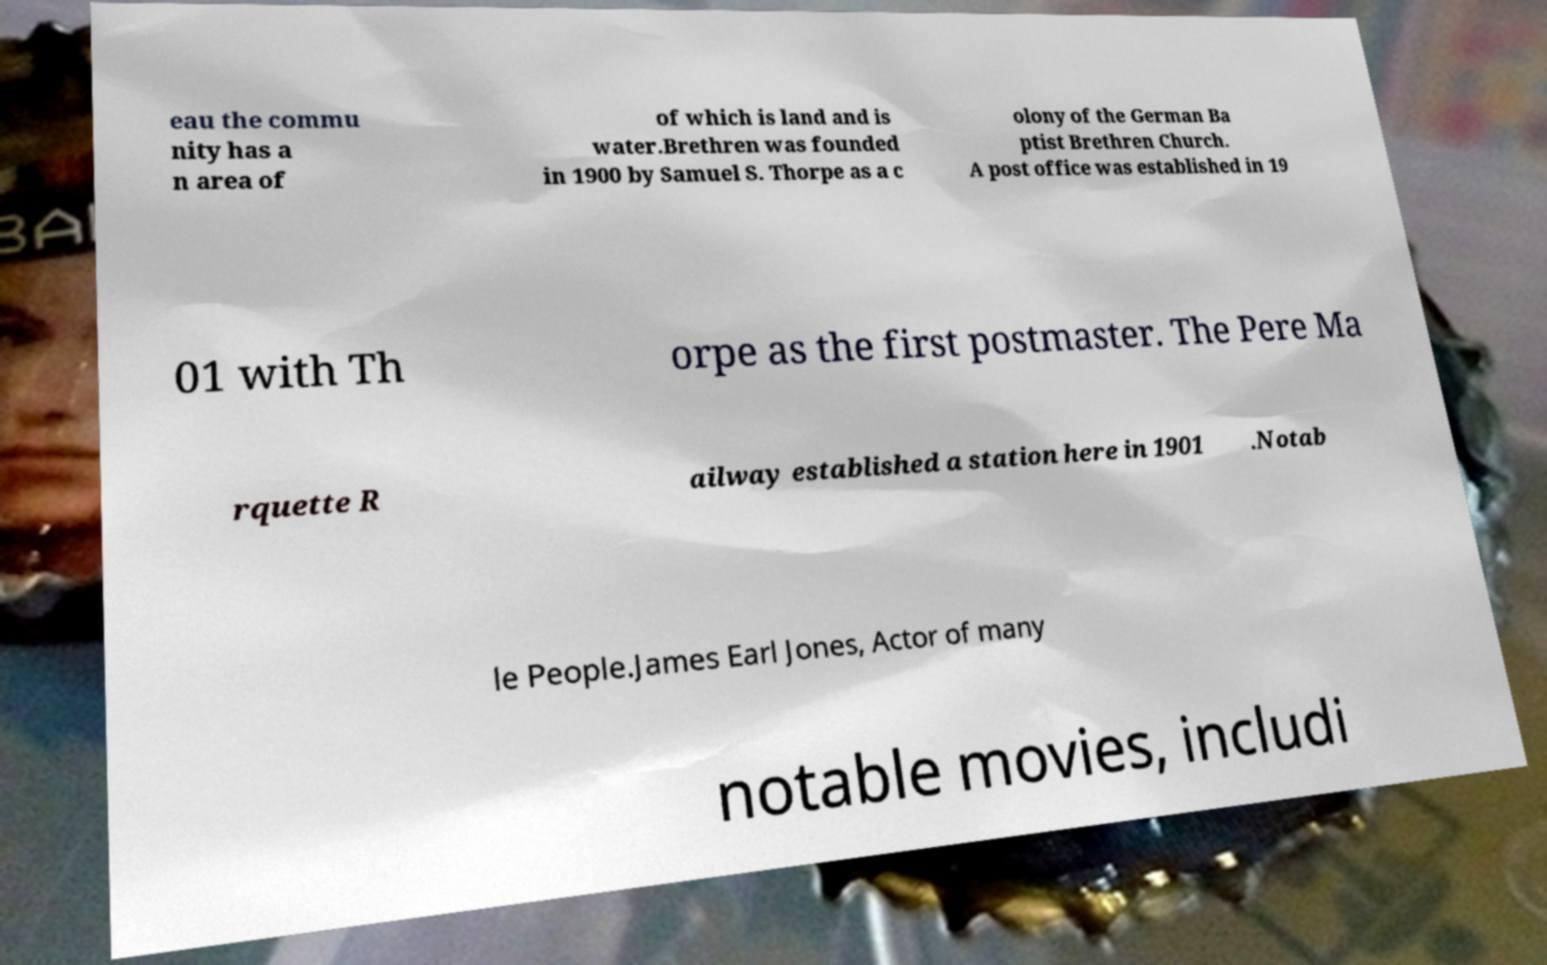Can you accurately transcribe the text from the provided image for me? eau the commu nity has a n area of of which is land and is water.Brethren was founded in 1900 by Samuel S. Thorpe as a c olony of the German Ba ptist Brethren Church. A post office was established in 19 01 with Th orpe as the first postmaster. The Pere Ma rquette R ailway established a station here in 1901 .Notab le People.James Earl Jones, Actor of many notable movies, includi 